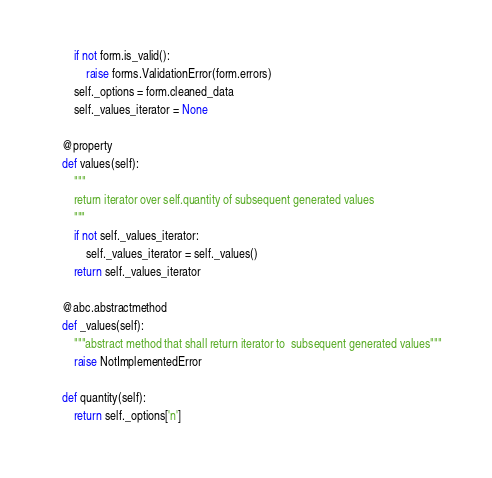Convert code to text. <code><loc_0><loc_0><loc_500><loc_500><_Python_>        if not form.is_valid():
            raise forms.ValidationError(form.errors)
        self._options = form.cleaned_data
        self._values_iterator = None

    @property
    def values(self):
        """
        return iterator over self.quantity of subsequent generated values
        """
        if not self._values_iterator:
            self._values_iterator = self._values()
        return self._values_iterator

    @abc.abstractmethod
    def _values(self):
        """abstract method that shall return iterator to  subsequent generated values"""
        raise NotImplementedError

    def quantity(self):
        return self._options['n']</code> 